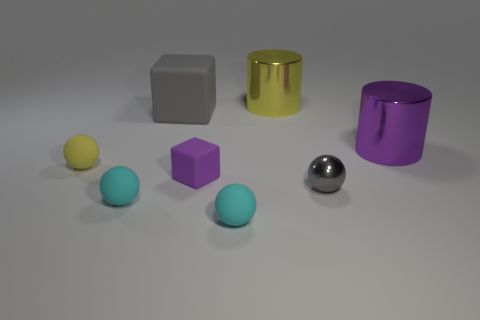Subtract 1 balls. How many balls are left? 3 Add 1 small purple rubber cubes. How many objects exist? 9 Subtract all cylinders. How many objects are left? 6 Subtract 0 purple balls. How many objects are left? 8 Subtract all cyan matte balls. Subtract all purple metallic objects. How many objects are left? 5 Add 7 cyan objects. How many cyan objects are left? 9 Add 6 gray cubes. How many gray cubes exist? 7 